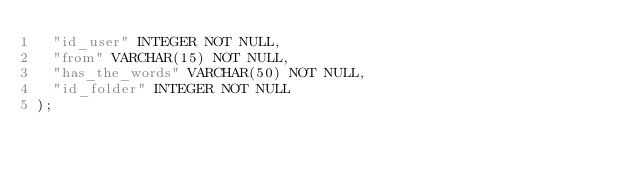Convert code to text. <code><loc_0><loc_0><loc_500><loc_500><_SQL_>  "id_user" INTEGER NOT NULL,
  "from" VARCHAR(15) NOT NULL,
  "has_the_words" VARCHAR(50) NOT NULL,
  "id_folder" INTEGER NOT NULL
);</code> 